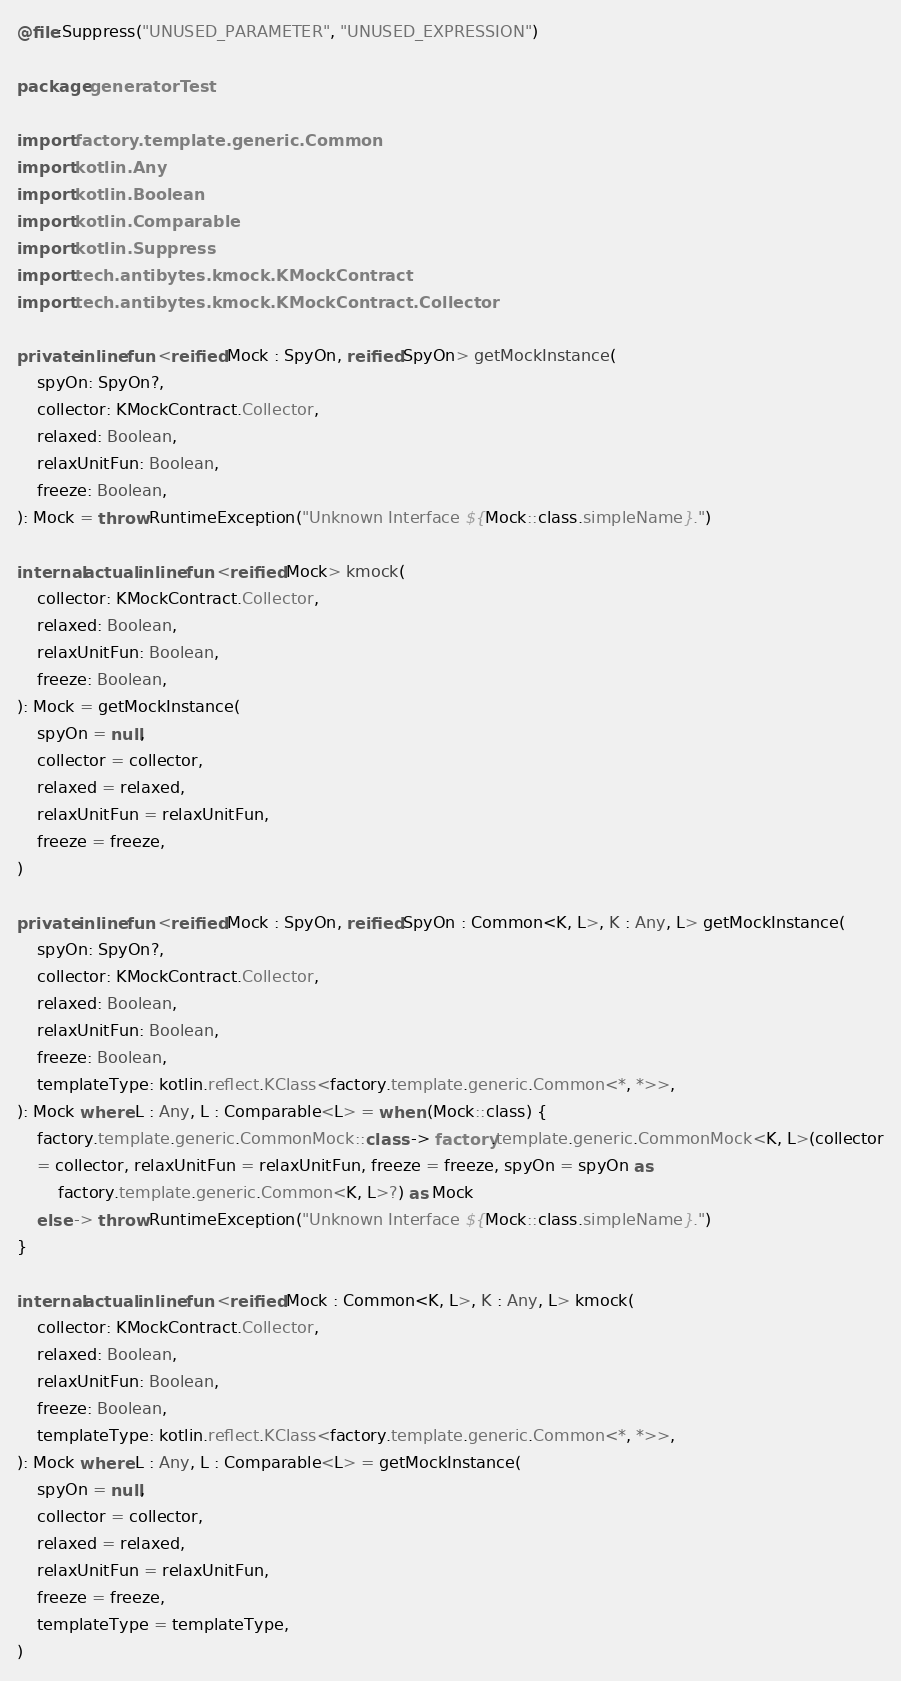<code> <loc_0><loc_0><loc_500><loc_500><_Kotlin_>@file:Suppress("UNUSED_PARAMETER", "UNUSED_EXPRESSION")

package generatorTest

import factory.template.generic.Common
import kotlin.Any
import kotlin.Boolean
import kotlin.Comparable
import kotlin.Suppress
import tech.antibytes.kmock.KMockContract
import tech.antibytes.kmock.KMockContract.Collector

private inline fun <reified Mock : SpyOn, reified SpyOn> getMockInstance(
    spyOn: SpyOn?,
    collector: KMockContract.Collector,
    relaxed: Boolean,
    relaxUnitFun: Boolean,
    freeze: Boolean,
): Mock = throw RuntimeException("Unknown Interface ${Mock::class.simpleName}.")

internal actual inline fun <reified Mock> kmock(
    collector: KMockContract.Collector,
    relaxed: Boolean,
    relaxUnitFun: Boolean,
    freeze: Boolean,
): Mock = getMockInstance(
    spyOn = null,
    collector = collector,
    relaxed = relaxed,
    relaxUnitFun = relaxUnitFun,
    freeze = freeze,
)

private inline fun <reified Mock : SpyOn, reified SpyOn : Common<K, L>, K : Any, L> getMockInstance(
    spyOn: SpyOn?,
    collector: KMockContract.Collector,
    relaxed: Boolean,
    relaxUnitFun: Boolean,
    freeze: Boolean,
    templateType: kotlin.reflect.KClass<factory.template.generic.Common<*, *>>,
): Mock where L : Any, L : Comparable<L> = when (Mock::class) {
    factory.template.generic.CommonMock::class -> factory.template.generic.CommonMock<K, L>(collector
    = collector, relaxUnitFun = relaxUnitFun, freeze = freeze, spyOn = spyOn as
        factory.template.generic.Common<K, L>?) as Mock
    else -> throw RuntimeException("Unknown Interface ${Mock::class.simpleName}.")
}

internal actual inline fun <reified Mock : Common<K, L>, K : Any, L> kmock(
    collector: KMockContract.Collector,
    relaxed: Boolean,
    relaxUnitFun: Boolean,
    freeze: Boolean,
    templateType: kotlin.reflect.KClass<factory.template.generic.Common<*, *>>,
): Mock where L : Any, L : Comparable<L> = getMockInstance(
    spyOn = null,
    collector = collector,
    relaxed = relaxed,
    relaxUnitFun = relaxUnitFun,
    freeze = freeze,
    templateType = templateType,
)
</code> 